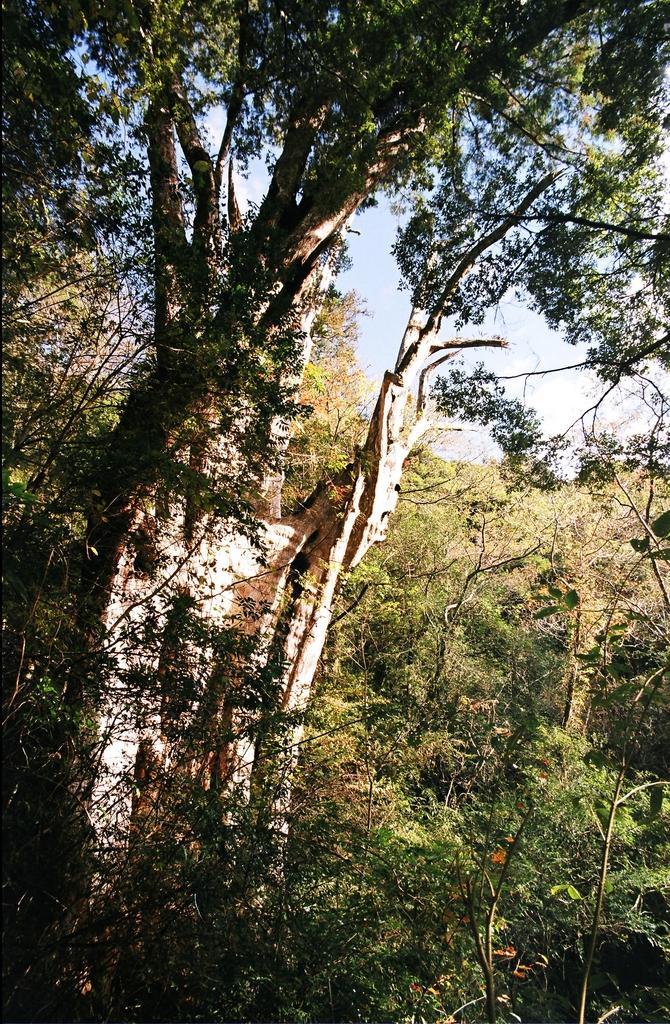Please provide a concise description of this image. In this picture there is greenery in the image. 